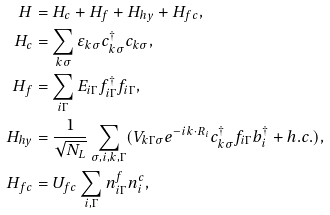Convert formula to latex. <formula><loc_0><loc_0><loc_500><loc_500>H & = H _ { c } + H _ { f } + H _ { h y } + H _ { f c } , \\ H _ { c } & = \sum _ { { k } \sigma } \varepsilon _ { { k } \sigma } c ^ { \dag } _ { { k } \sigma } c _ { { k } \sigma } , \\ H _ { f } & = \sum _ { i \Gamma } E _ { i \Gamma } f _ { i \Gamma } ^ { \dag } f _ { i \Gamma } , \\ H _ { h y } & = \frac { 1 } { \sqrt { N _ { L } } } \sum _ { \sigma , i , { k } , \Gamma } ( V _ { { k } \Gamma \sigma } e ^ { - i { k } \cdot { R } _ { i } } c _ { { k } \sigma } ^ { \dag } f _ { i \Gamma } b ^ { \dag } _ { i } + h . c . ) , \\ H _ { f c } & = U _ { f c } \sum _ { i , \Gamma } n ^ { f } _ { i \Gamma } n ^ { c } _ { i } ,</formula> 